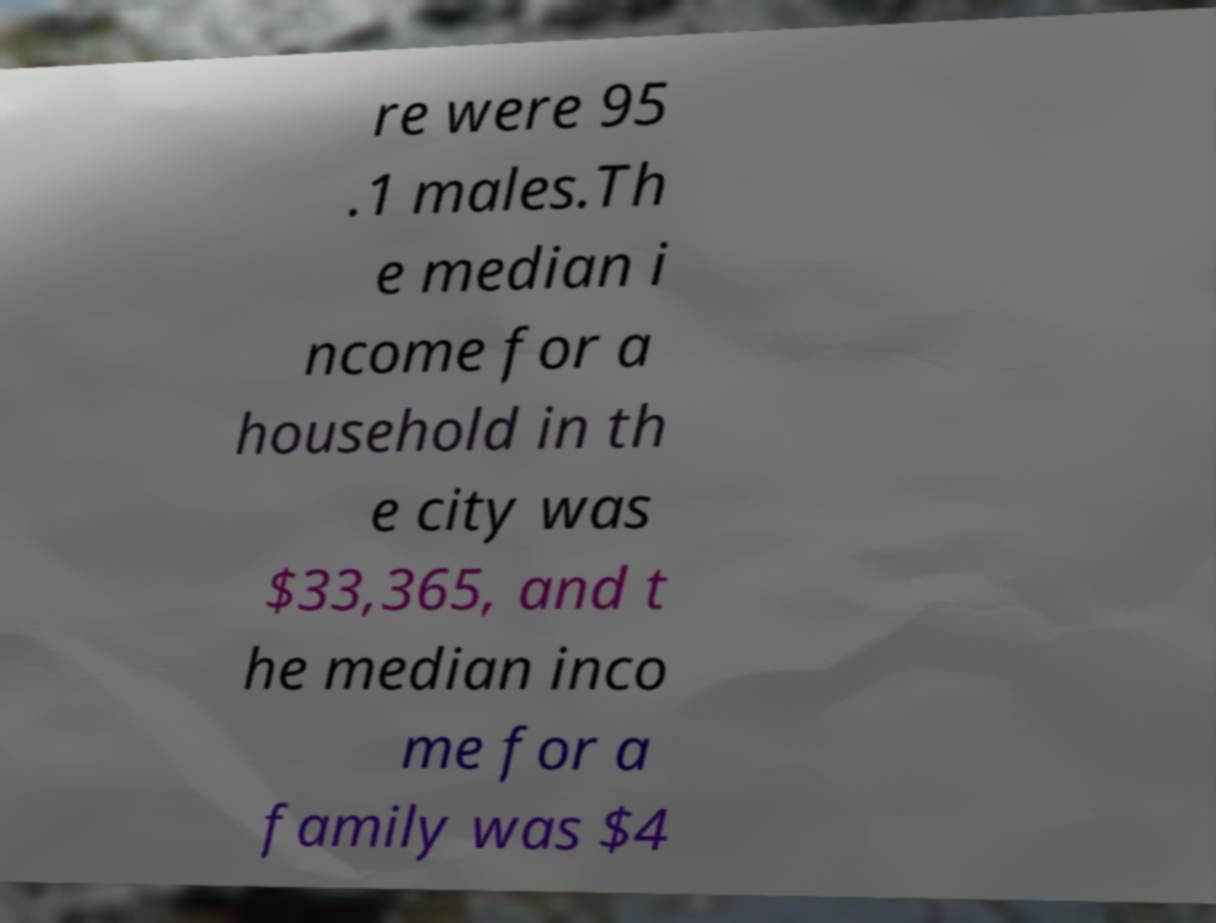Can you read and provide the text displayed in the image?This photo seems to have some interesting text. Can you extract and type it out for me? re were 95 .1 males.Th e median i ncome for a household in th e city was $33,365, and t he median inco me for a family was $4 